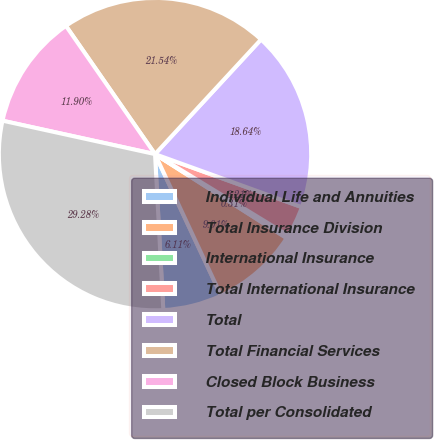<chart> <loc_0><loc_0><loc_500><loc_500><pie_chart><fcel>Individual Life and Annuities<fcel>Total Insurance Division<fcel>International Insurance<fcel>Total International Insurance<fcel>Total<fcel>Total Financial Services<fcel>Closed Block Business<fcel>Total per Consolidated<nl><fcel>6.11%<fcel>9.01%<fcel>0.31%<fcel>3.21%<fcel>18.64%<fcel>21.54%<fcel>11.9%<fcel>29.28%<nl></chart> 